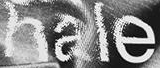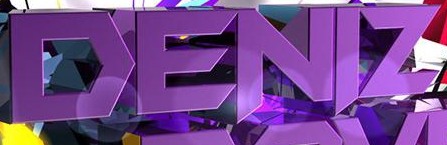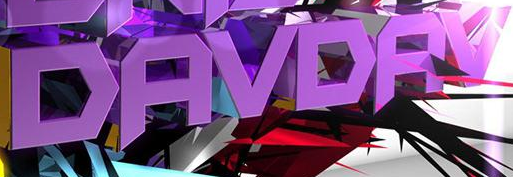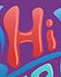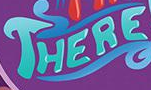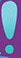What words are shown in these images in order, separated by a semicolon? hale; DENIZ; DAVDAV; Hi; THERE; ! 